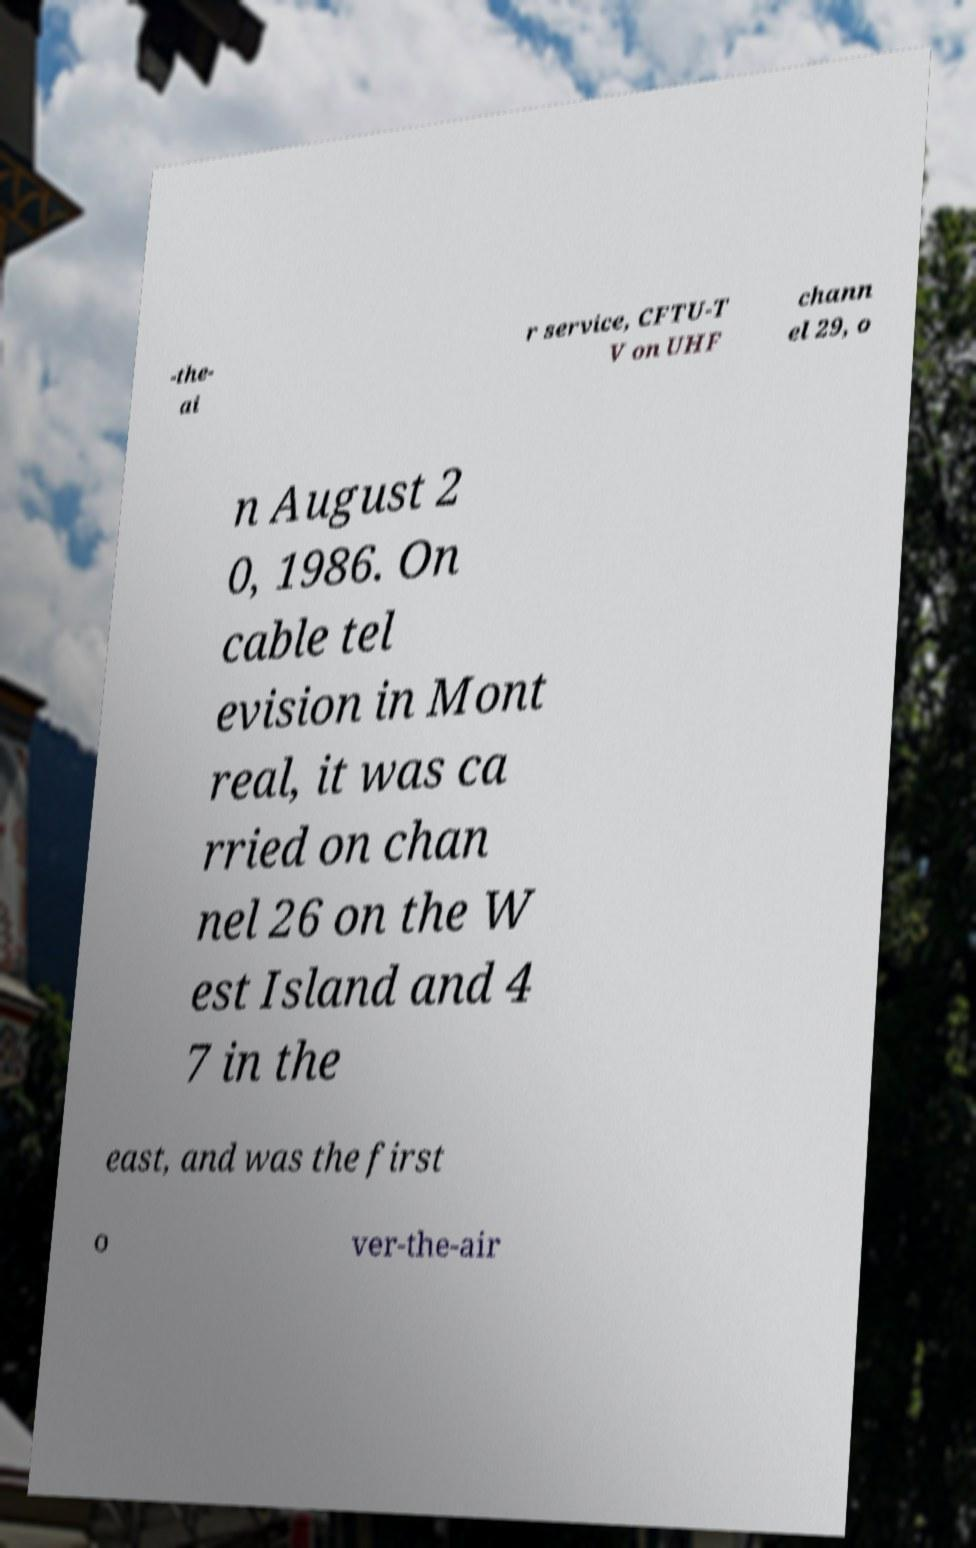For documentation purposes, I need the text within this image transcribed. Could you provide that? -the- ai r service, CFTU-T V on UHF chann el 29, o n August 2 0, 1986. On cable tel evision in Mont real, it was ca rried on chan nel 26 on the W est Island and 4 7 in the east, and was the first o ver-the-air 